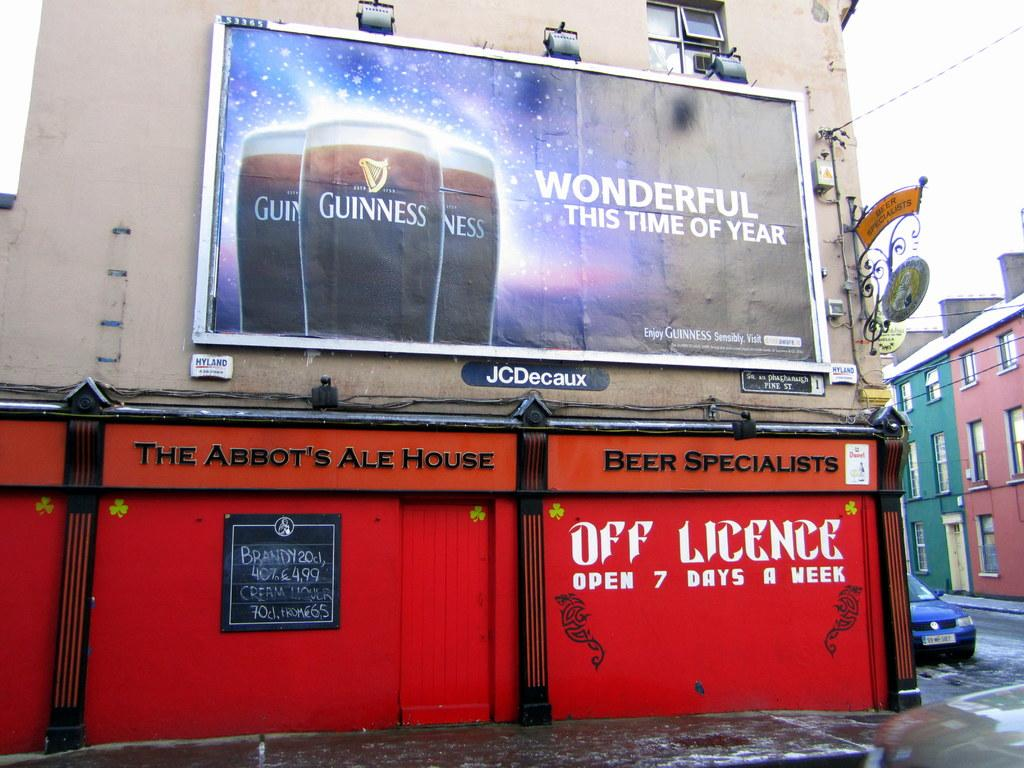<image>
Summarize the visual content of the image. A Guiness billboard that says wonderful this time of year. 